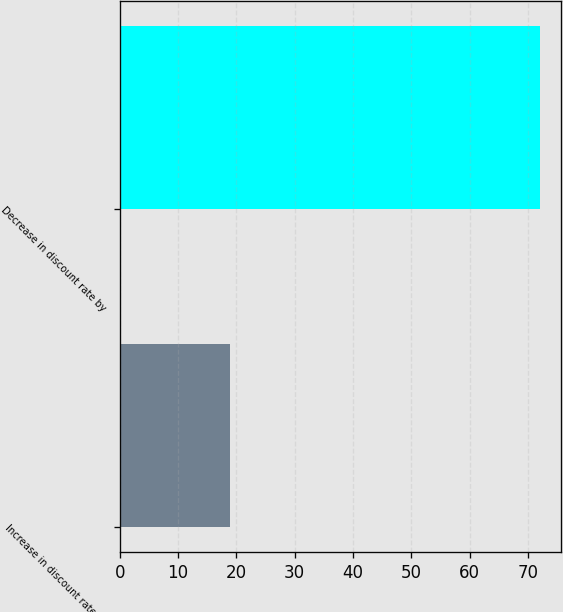Convert chart to OTSL. <chart><loc_0><loc_0><loc_500><loc_500><bar_chart><fcel>Increase in discount rate by<fcel>Decrease in discount rate by<nl><fcel>19<fcel>72<nl></chart> 